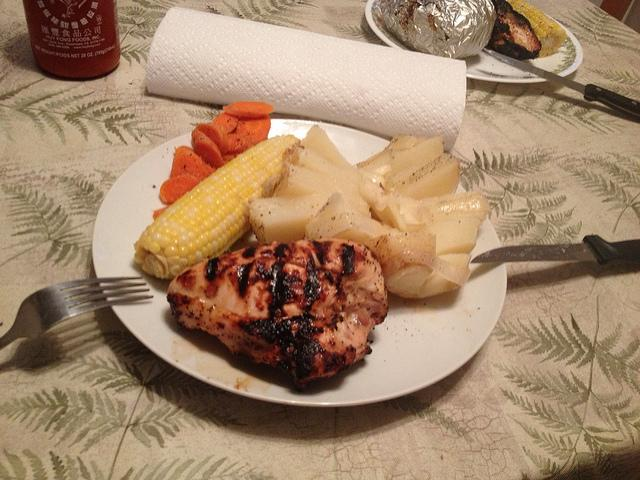What was used to cook the meat and potatoes of the dish? grill 